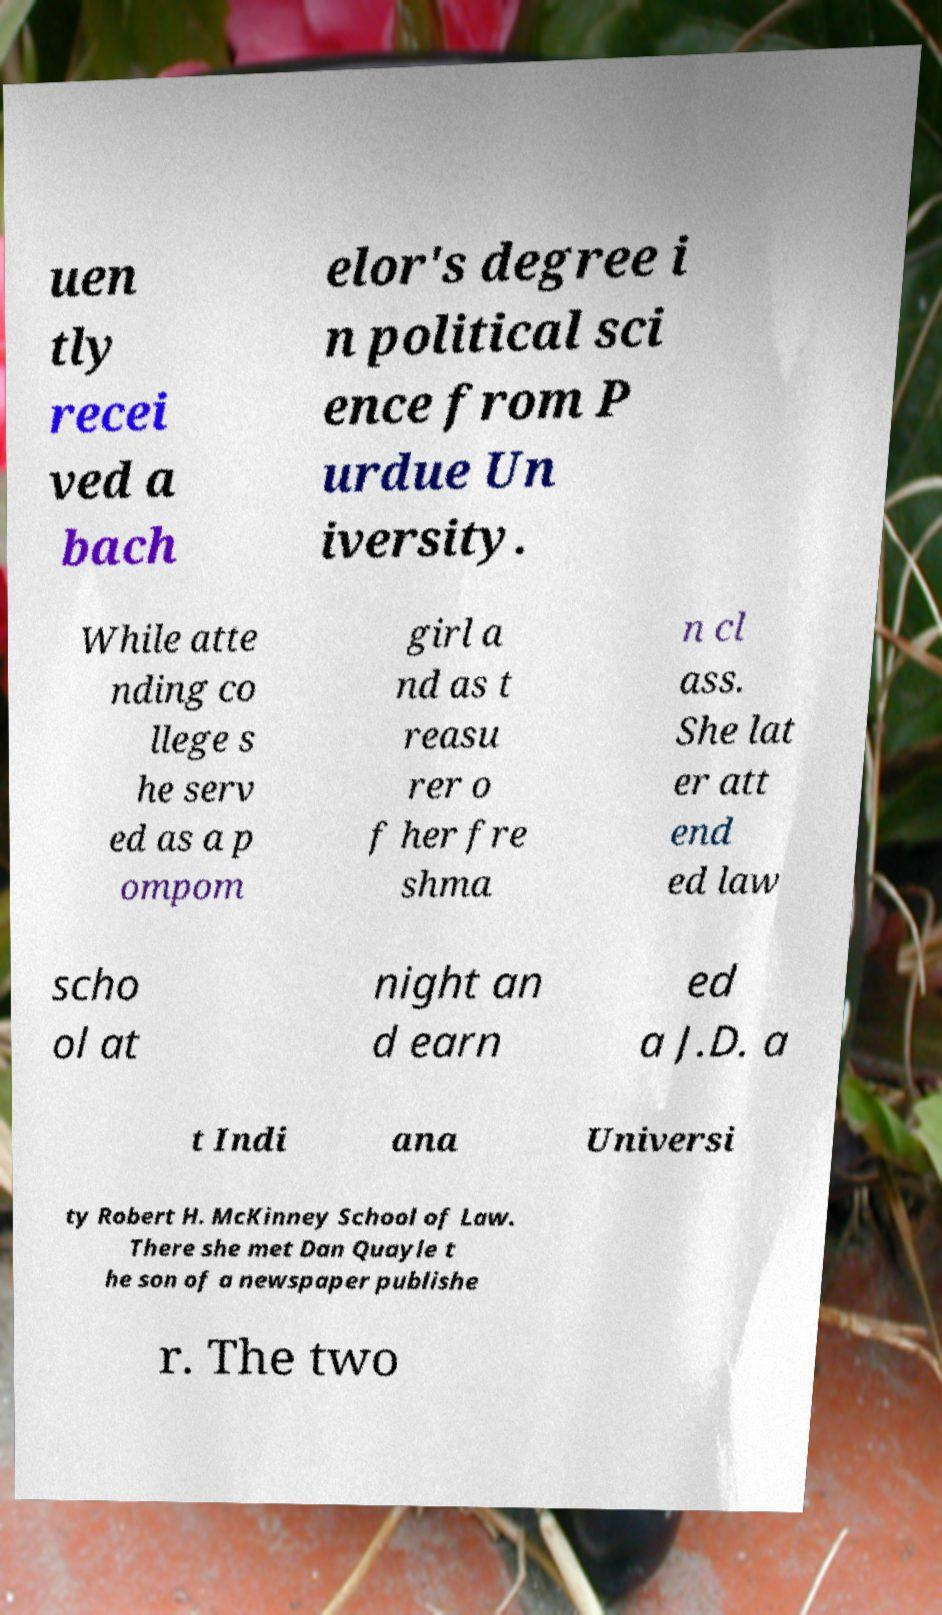Please identify and transcribe the text found in this image. uen tly recei ved a bach elor's degree i n political sci ence from P urdue Un iversity. While atte nding co llege s he serv ed as a p ompom girl a nd as t reasu rer o f her fre shma n cl ass. She lat er att end ed law scho ol at night an d earn ed a J.D. a t Indi ana Universi ty Robert H. McKinney School of Law. There she met Dan Quayle t he son of a newspaper publishe r. The two 